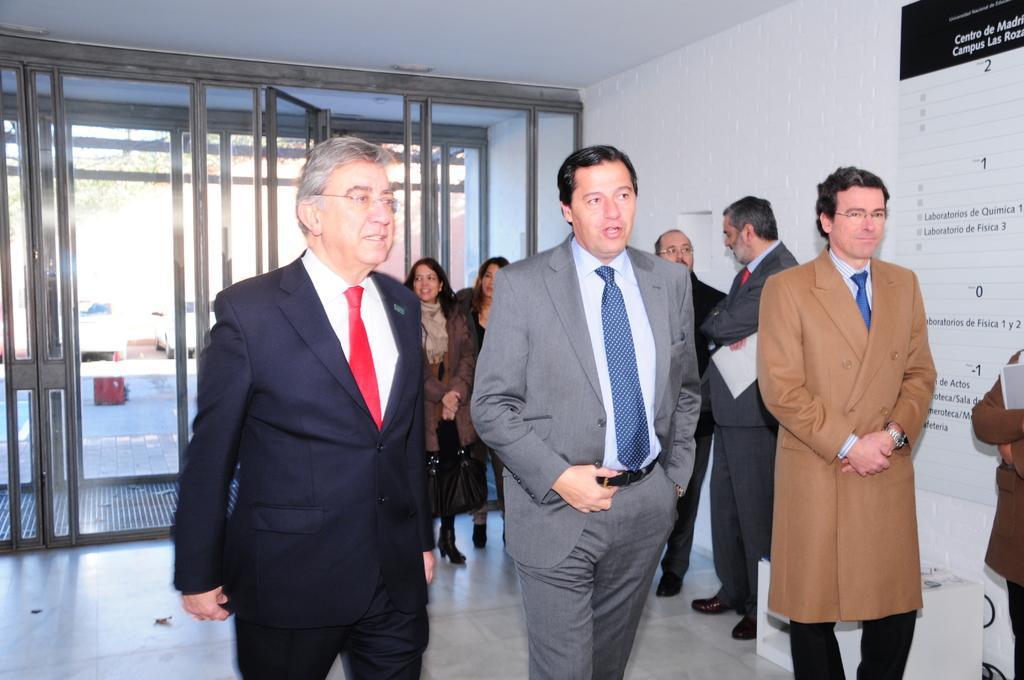Describe this image in one or two sentences. In this image we can see people. On the right there is a board placed on the wall and we can see a stand. In the background there are cars and doors. 